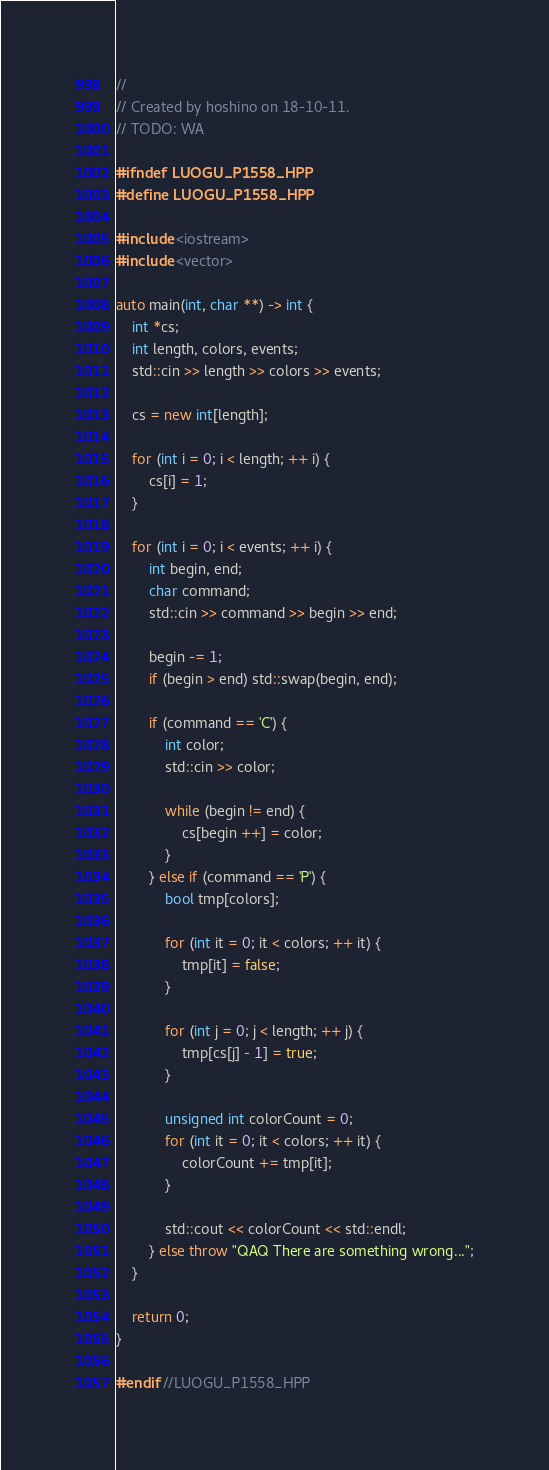<code> <loc_0><loc_0><loc_500><loc_500><_C++_>//
// Created by hoshino on 18-10-11.
// TODO: WA

#ifndef LUOGU_P1558_HPP
#define LUOGU_P1558_HPP

#include <iostream>
#include <vector>

auto main(int, char **) -> int {
	int *cs;
	int length, colors, events;
	std::cin >> length >> colors >> events;

	cs = new int[length];

	for (int i = 0; i < length; ++ i) {
		cs[i] = 1;
	}

	for (int i = 0; i < events; ++ i) {
		int begin, end;
		char command;
		std::cin >> command >> begin >> end;

		begin -= 1;
		if (begin > end) std::swap(begin, end);

		if (command == 'C') {
			int color;
			std::cin >> color;

			while (begin != end) {
				cs[begin ++] = color;
			}
		} else if (command == 'P') {
			bool tmp[colors];

			for (int it = 0; it < colors; ++ it) {
				tmp[it] = false;
			}

			for (int j = 0; j < length; ++ j) {
				tmp[cs[j] - 1] = true;
			}

			unsigned int colorCount = 0;
			for (int it = 0; it < colors; ++ it) {
				colorCount += tmp[it];
			}

			std::cout << colorCount << std::endl;
		} else throw "QAQ There are something wrong...";
	}

	return 0;
}

#endif //LUOGU_P1558_HPP
</code> 